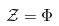Convert formula to latex. <formula><loc_0><loc_0><loc_500><loc_500>\mathcal { Z } = \Phi</formula> 